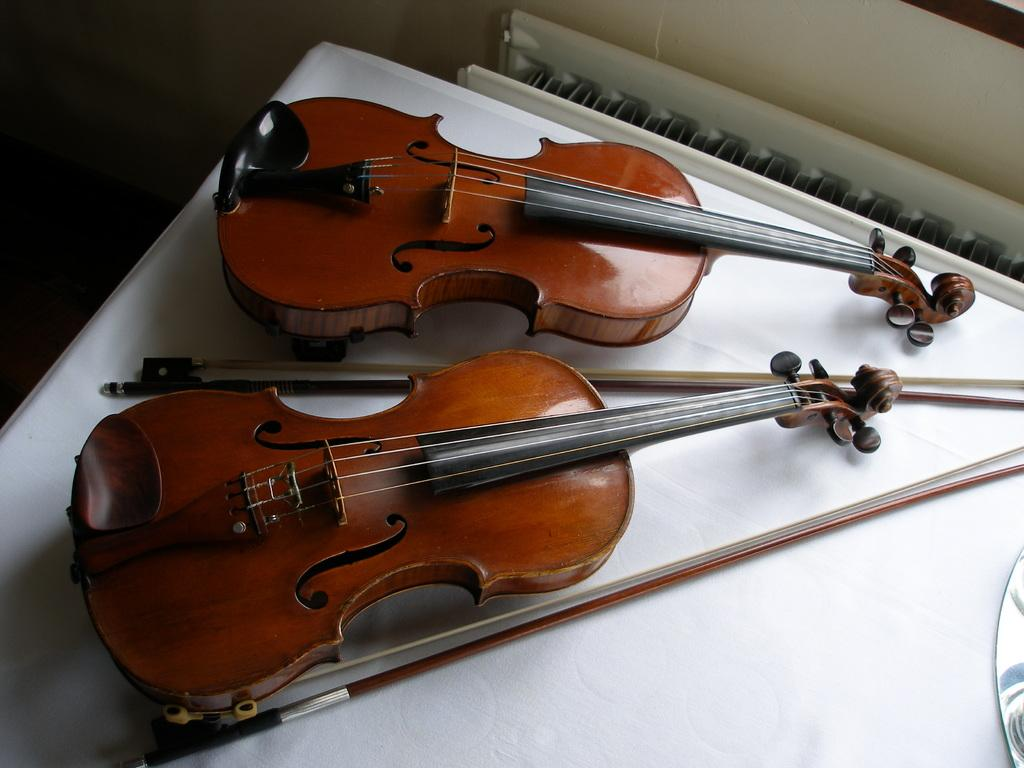What is the main object in the image? There is a table in the image. What musical instruments are on the table? There are two violins on the table. What are the accompanying items for the violins? There are two violin sticks on the table. How does the credit card help the violinist in the image? There is no credit card present in the image, so it cannot help the violinist. 